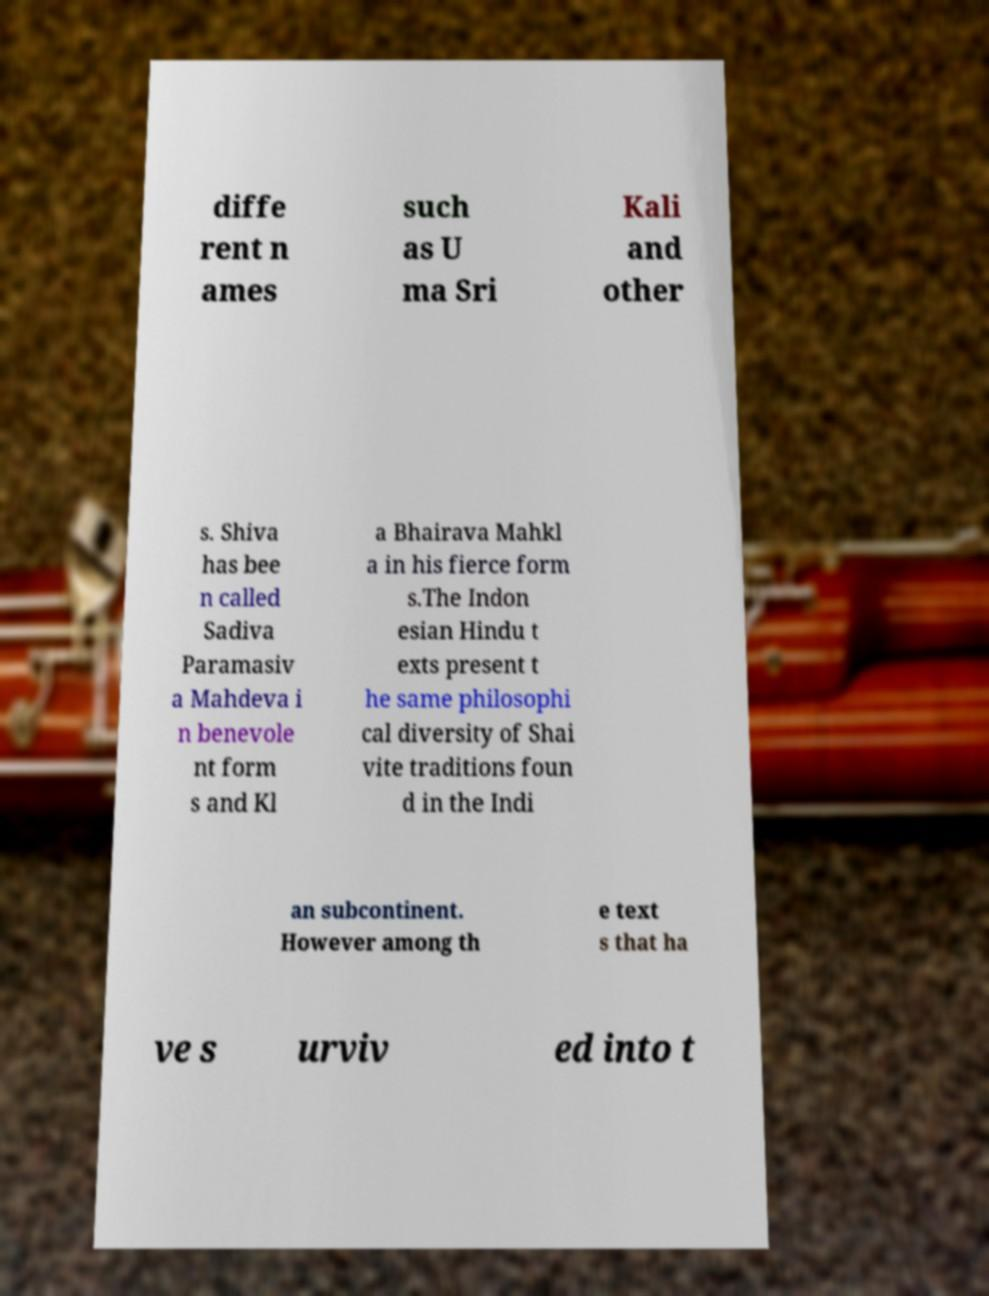There's text embedded in this image that I need extracted. Can you transcribe it verbatim? diffe rent n ames such as U ma Sri Kali and other s. Shiva has bee n called Sadiva Paramasiv a Mahdeva i n benevole nt form s and Kl a Bhairava Mahkl a in his fierce form s.The Indon esian Hindu t exts present t he same philosophi cal diversity of Shai vite traditions foun d in the Indi an subcontinent. However among th e text s that ha ve s urviv ed into t 